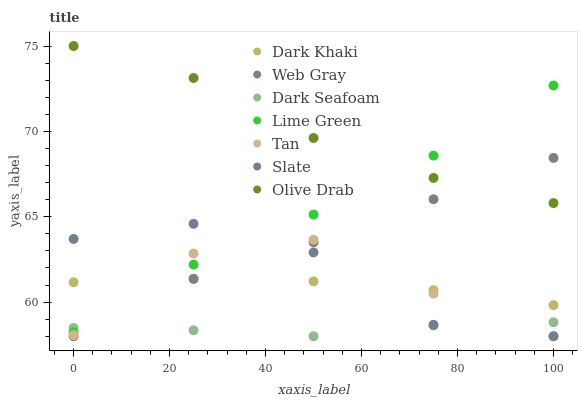Does Dark Seafoam have the minimum area under the curve?
Answer yes or no. Yes. Does Olive Drab have the maximum area under the curve?
Answer yes or no. Yes. Does Slate have the minimum area under the curve?
Answer yes or no. No. Does Slate have the maximum area under the curve?
Answer yes or no. No. Is Dark Khaki the smoothest?
Answer yes or no. Yes. Is Slate the roughest?
Answer yes or no. Yes. Is Slate the smoothest?
Answer yes or no. No. Is Dark Khaki the roughest?
Answer yes or no. No. Does Web Gray have the lowest value?
Answer yes or no. Yes. Does Dark Khaki have the lowest value?
Answer yes or no. No. Does Olive Drab have the highest value?
Answer yes or no. Yes. Does Slate have the highest value?
Answer yes or no. No. Is Dark Khaki less than Olive Drab?
Answer yes or no. Yes. Is Lime Green greater than Web Gray?
Answer yes or no. Yes. Does Web Gray intersect Tan?
Answer yes or no. Yes. Is Web Gray less than Tan?
Answer yes or no. No. Is Web Gray greater than Tan?
Answer yes or no. No. Does Dark Khaki intersect Olive Drab?
Answer yes or no. No. 